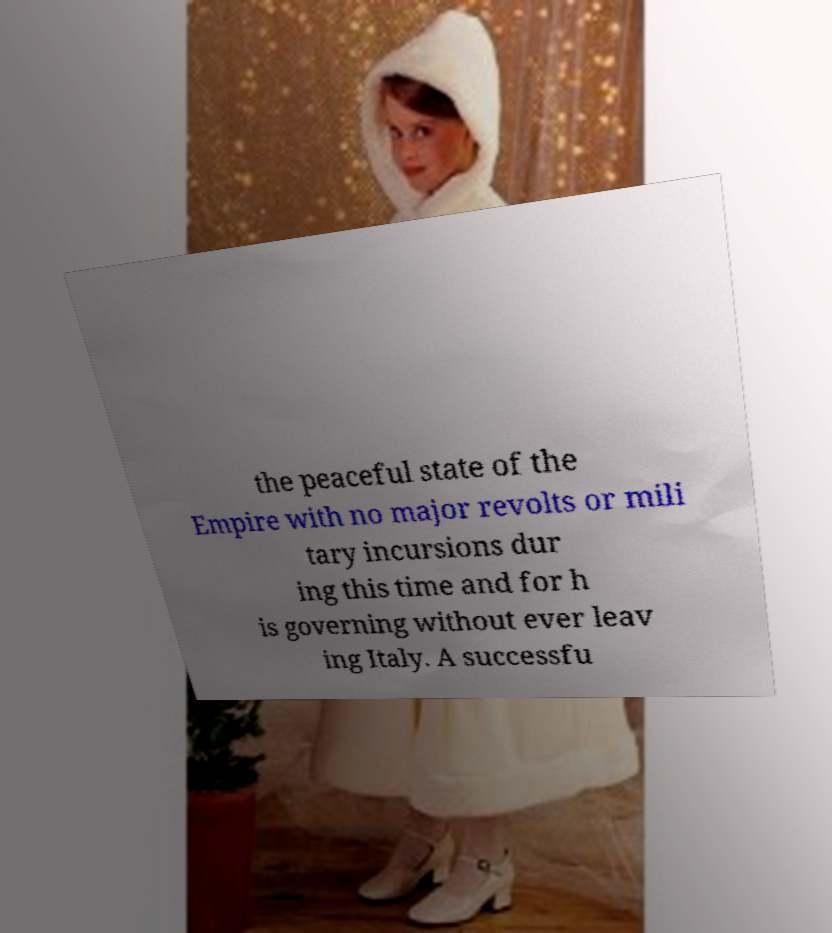Could you extract and type out the text from this image? the peaceful state of the Empire with no major revolts or mili tary incursions dur ing this time and for h is governing without ever leav ing Italy. A successfu 